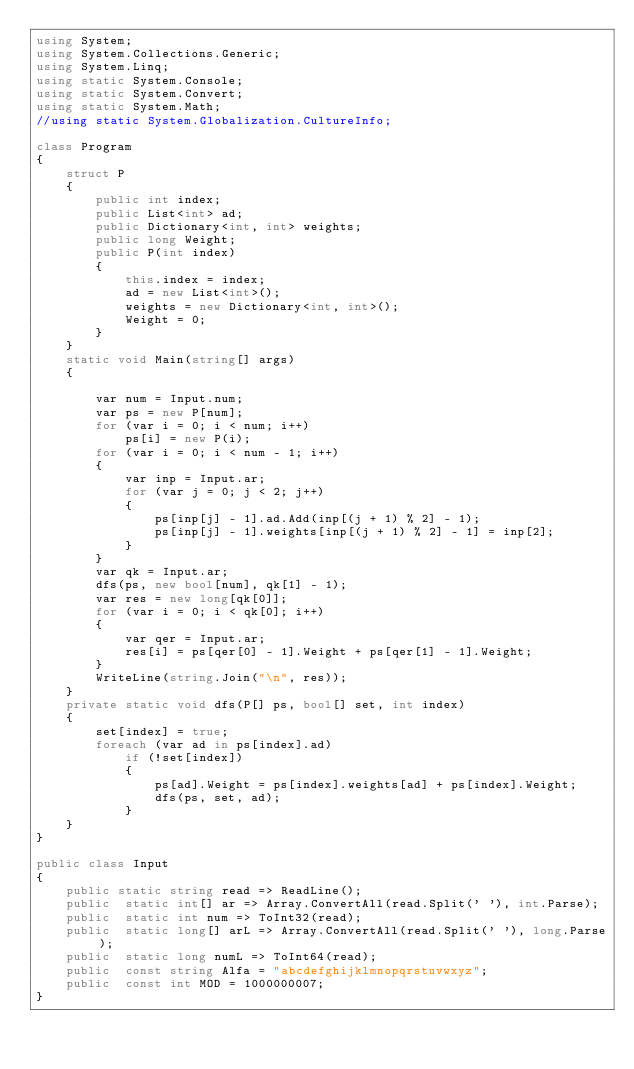Convert code to text. <code><loc_0><loc_0><loc_500><loc_500><_C#_>using System;
using System.Collections.Generic;
using System.Linq;
using static System.Console;
using static System.Convert;
using static System.Math;
//using static System.Globalization.CultureInfo;

class Program
{
    struct P
    {
        public int index;
        public List<int> ad;
        public Dictionary<int, int> weights;
        public long Weight;
        public P(int index)
        {
            this.index = index;
            ad = new List<int>();
            weights = new Dictionary<int, int>();
            Weight = 0;
        }
    }
    static void Main(string[] args)
    {

        var num = Input.num;
        var ps = new P[num];
        for (var i = 0; i < num; i++)
            ps[i] = new P(i);
        for (var i = 0; i < num - 1; i++)
        {
            var inp = Input.ar;
            for (var j = 0; j < 2; j++)
            {
                ps[inp[j] - 1].ad.Add(inp[(j + 1) % 2] - 1);
                ps[inp[j] - 1].weights[inp[(j + 1) % 2] - 1] = inp[2];
            }
        }
        var qk = Input.ar;
        dfs(ps, new bool[num], qk[1] - 1);
        var res = new long[qk[0]];
        for (var i = 0; i < qk[0]; i++)
        {
            var qer = Input.ar;
            res[i] = ps[qer[0] - 1].Weight + ps[qer[1] - 1].Weight;
        }
        WriteLine(string.Join("\n", res));
    }
    private static void dfs(P[] ps, bool[] set, int index)
    {
        set[index] = true;
        foreach (var ad in ps[index].ad)
            if (!set[index])
            {
                ps[ad].Weight = ps[index].weights[ad] + ps[index].Weight;
                dfs(ps, set, ad);
            }
    }
}

public class Input
{
    public static string read => ReadLine();
    public  static int[] ar => Array.ConvertAll(read.Split(' '), int.Parse);
    public  static int num => ToInt32(read);
    public  static long[] arL => Array.ConvertAll(read.Split(' '), long.Parse);
    public  static long numL => ToInt64(read);
    public  const string Alfa = "abcdefghijklmnopqrstuvwxyz";
    public  const int MOD = 1000000007;
}
</code> 